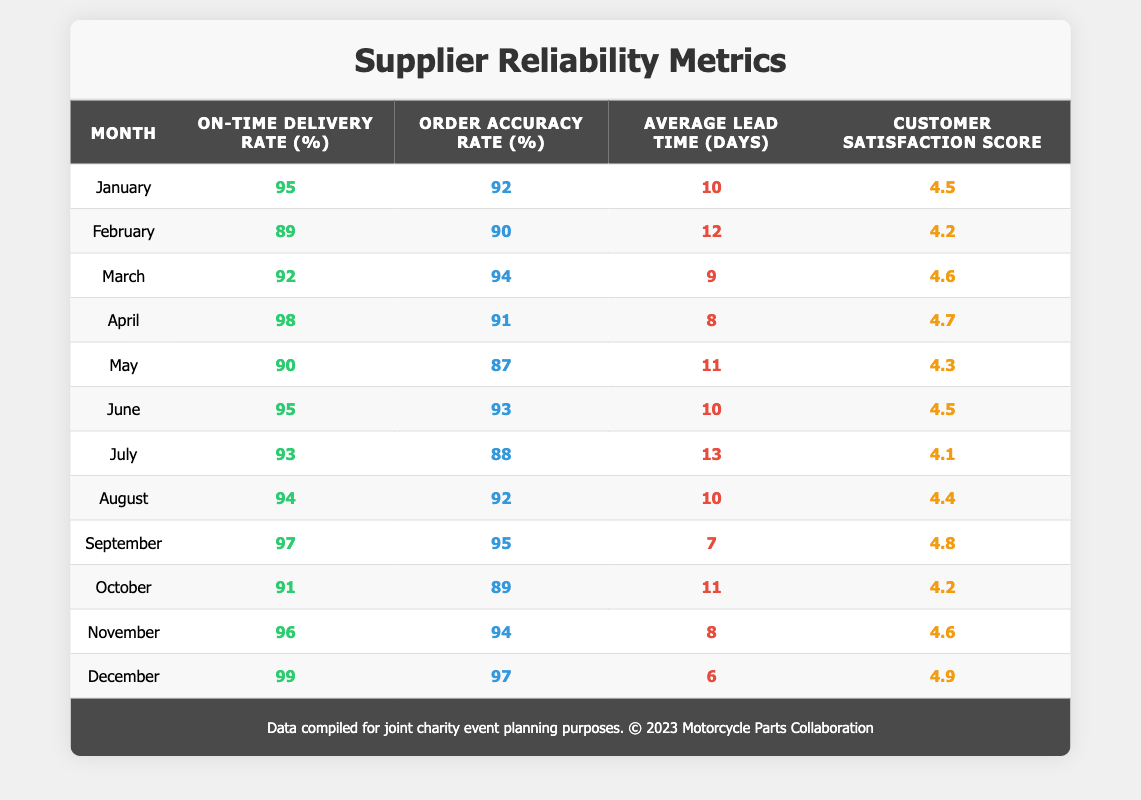What was the on-time delivery rate in December? Looking at the row for December, the on-time delivery rate is explicitly stated as 99%.
Answer: 99 Which month had the highest customer satisfaction score? By reviewing the customer satisfaction scores across all months, December has the highest score at 4.9, making it the month with the highest satisfaction.
Answer: December What is the average lead time over the year? To find the average lead time, add up all the lead times (10 + 12 + 9 + 8 + 11 + 10 + 13 + 10 + 7 + 11 + 8 + 6) =  5 + 110 = 134, and divide by the number of months (12), resulting in an average lead time of 134/12 = 11.17 days.
Answer: 11.17 Was the order accuracy rate in April higher than in January? In April, the order accuracy rate is 91%, while in January, it is 92%. Thus, April's rate is not higher than January's.
Answer: No What was the change in on-time delivery rate from February to March? The on-time delivery rate in February was 89%, and in March it was 92%. The change is 92 - 89 = 3 percentage points.
Answer: 3 Which month had the longest average lead time and what was it? By checking each month's average lead time, July has the longest lead time at 13 days.
Answer: July, 13 days How many months had an on-time delivery rate below 90%? From the table, February is the only month with an on-time delivery rate below 90%, which is 89%. So, there is 1 month with a rate below 90%.
Answer: 1 In which month did both the on-time delivery rate and customer satisfaction score increase? Comparing consecutive months, the on-time delivery rate increased from 89% in February to 92% in March, and the customer satisfaction score also increased from 4.2 in February to 4.6 in March, indicating a simultaneous increase in both metrics.
Answer: March What is the difference between the highest and lowest order accuracy rates? The highest order accuracy rate is 97% in December, while the lowest is 87% in May. The difference is 97 - 87 = 10 percentage points.
Answer: 10 